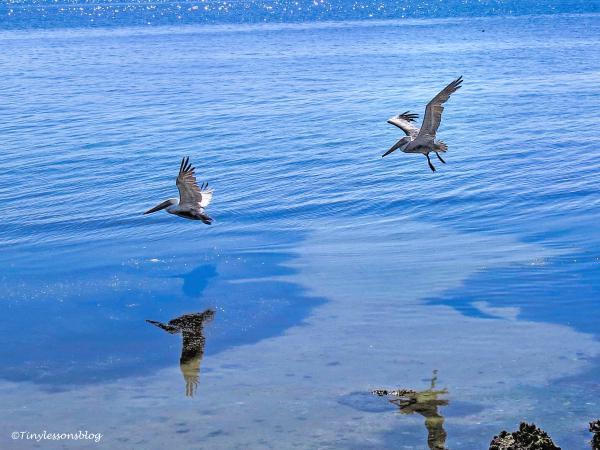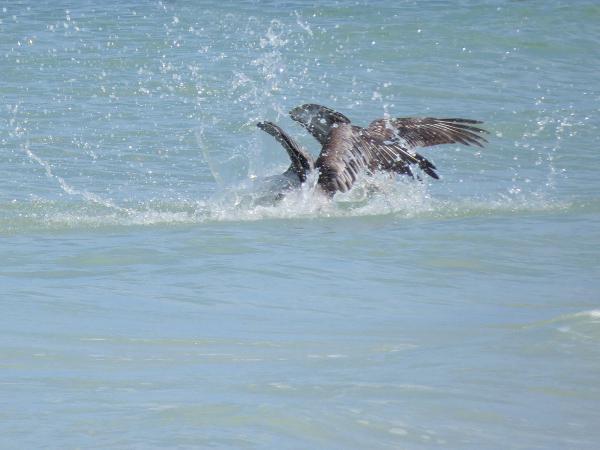The first image is the image on the left, the second image is the image on the right. Evaluate the accuracy of this statement regarding the images: "At least one pelican is diving for food with its head in the water.". Is it true? Answer yes or no. Yes. The first image is the image on the left, the second image is the image on the right. Given the left and right images, does the statement "One image shows two pelicans in flight above the water, and the other image shows two pelicans that have plunged into the water." hold true? Answer yes or no. Yes. 